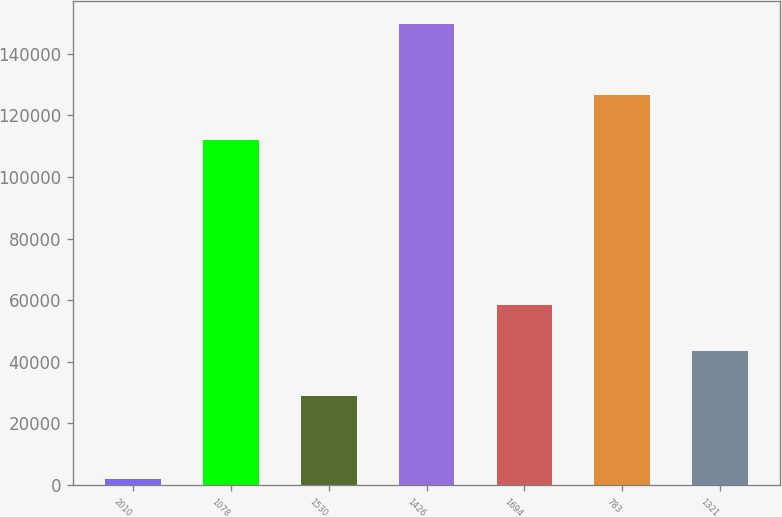<chart> <loc_0><loc_0><loc_500><loc_500><bar_chart><fcel>2010<fcel>1078<fcel>1530<fcel>1426<fcel>1694<fcel>783<fcel>1321<nl><fcel>2009<fcel>111916<fcel>28831<fcel>149528<fcel>58334.8<fcel>126668<fcel>43582.9<nl></chart> 